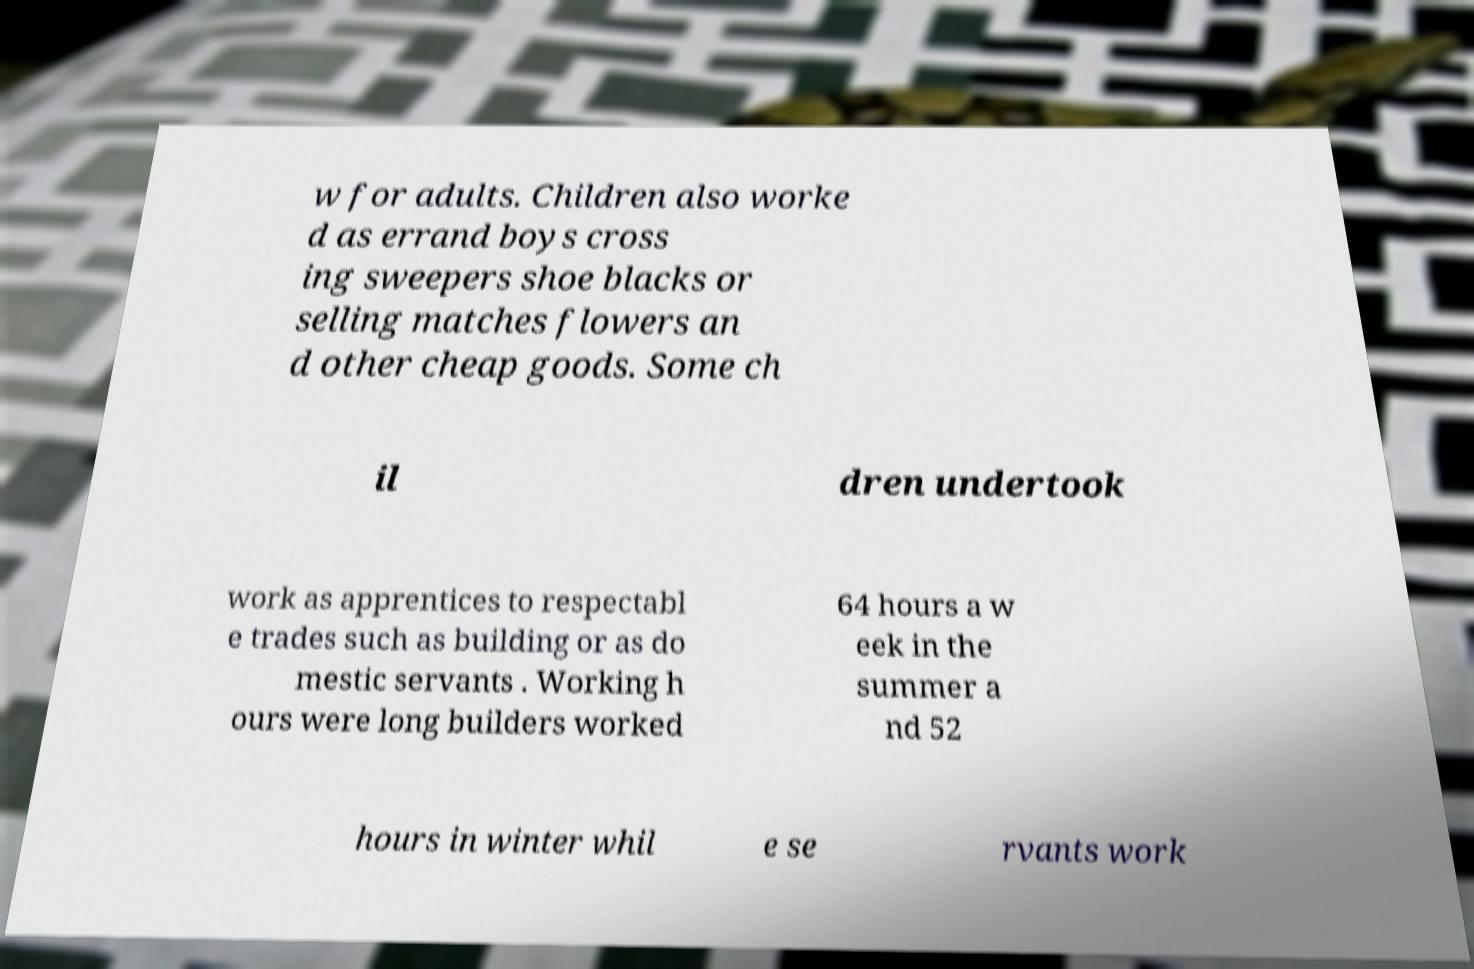What messages or text are displayed in this image? I need them in a readable, typed format. w for adults. Children also worke d as errand boys cross ing sweepers shoe blacks or selling matches flowers an d other cheap goods. Some ch il dren undertook work as apprentices to respectabl e trades such as building or as do mestic servants . Working h ours were long builders worked 64 hours a w eek in the summer a nd 52 hours in winter whil e se rvants work 